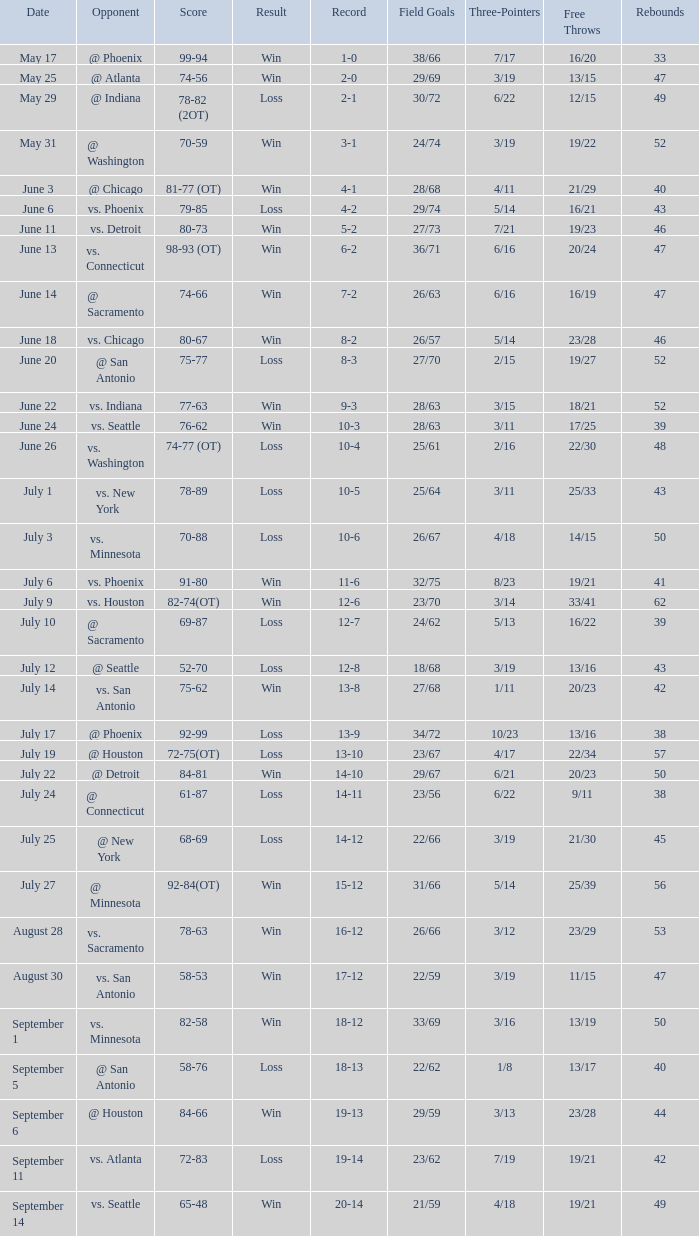What is the Record of the game on September 6? 19-13. 